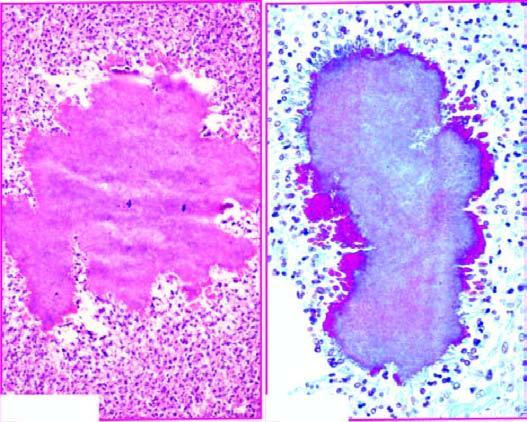what does the margin of the colony show?
Answer the question using a single word or phrase. Hyaline filaments highlighted by masson 's trichrome stain right photomicrograph 